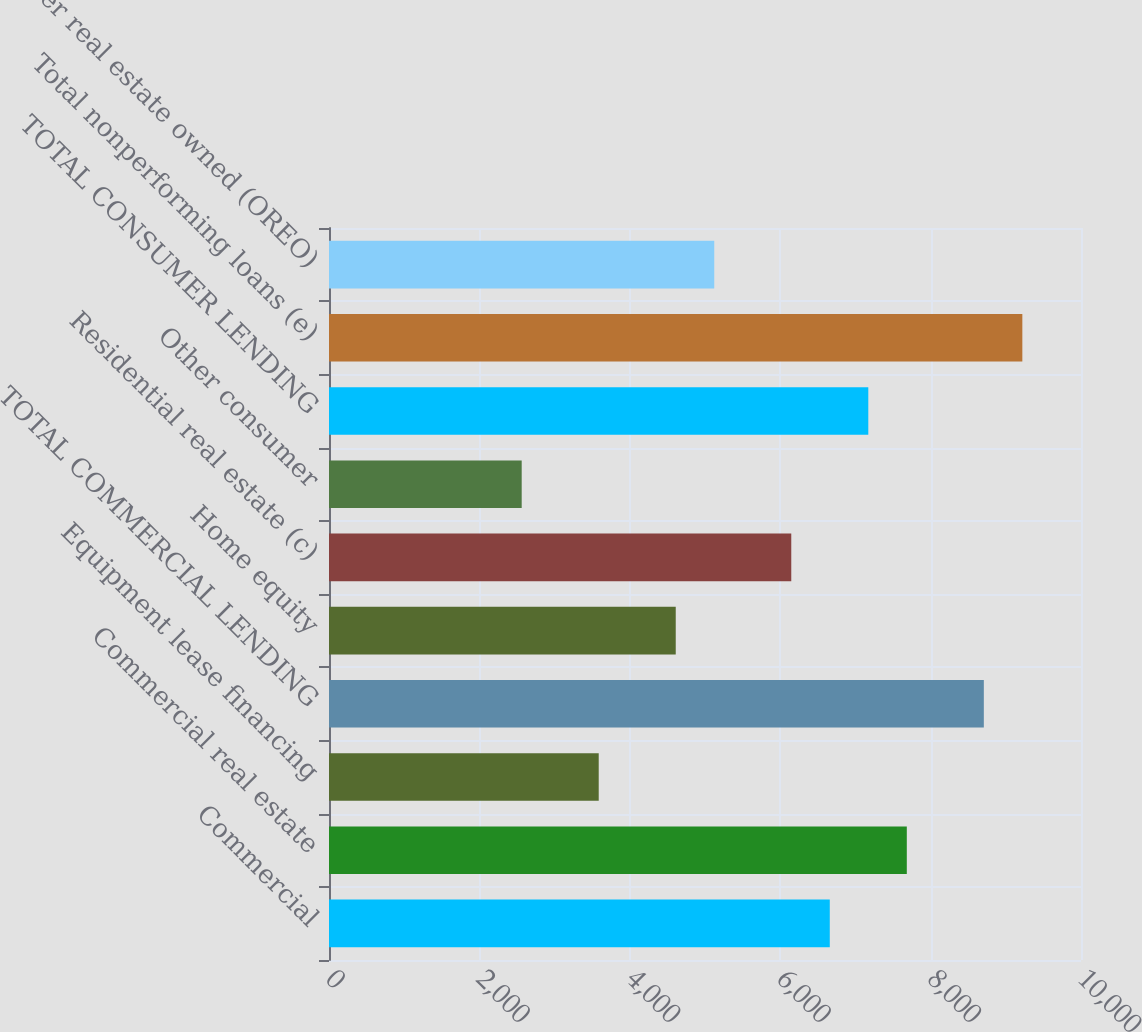Convert chart. <chart><loc_0><loc_0><loc_500><loc_500><bar_chart><fcel>Commercial<fcel>Commercial real estate<fcel>Equipment lease financing<fcel>TOTAL COMMERCIAL LENDING<fcel>Home equity<fcel>Residential real estate (c)<fcel>Other consumer<fcel>TOTAL CONSUMER LENDING<fcel>Total nonperforming loans (e)<fcel>Other real estate owned (OREO)<nl><fcel>6659.36<fcel>7683.6<fcel>3586.64<fcel>8707.84<fcel>4610.88<fcel>6147.24<fcel>2562.4<fcel>7171.48<fcel>9219.96<fcel>5123<nl></chart> 